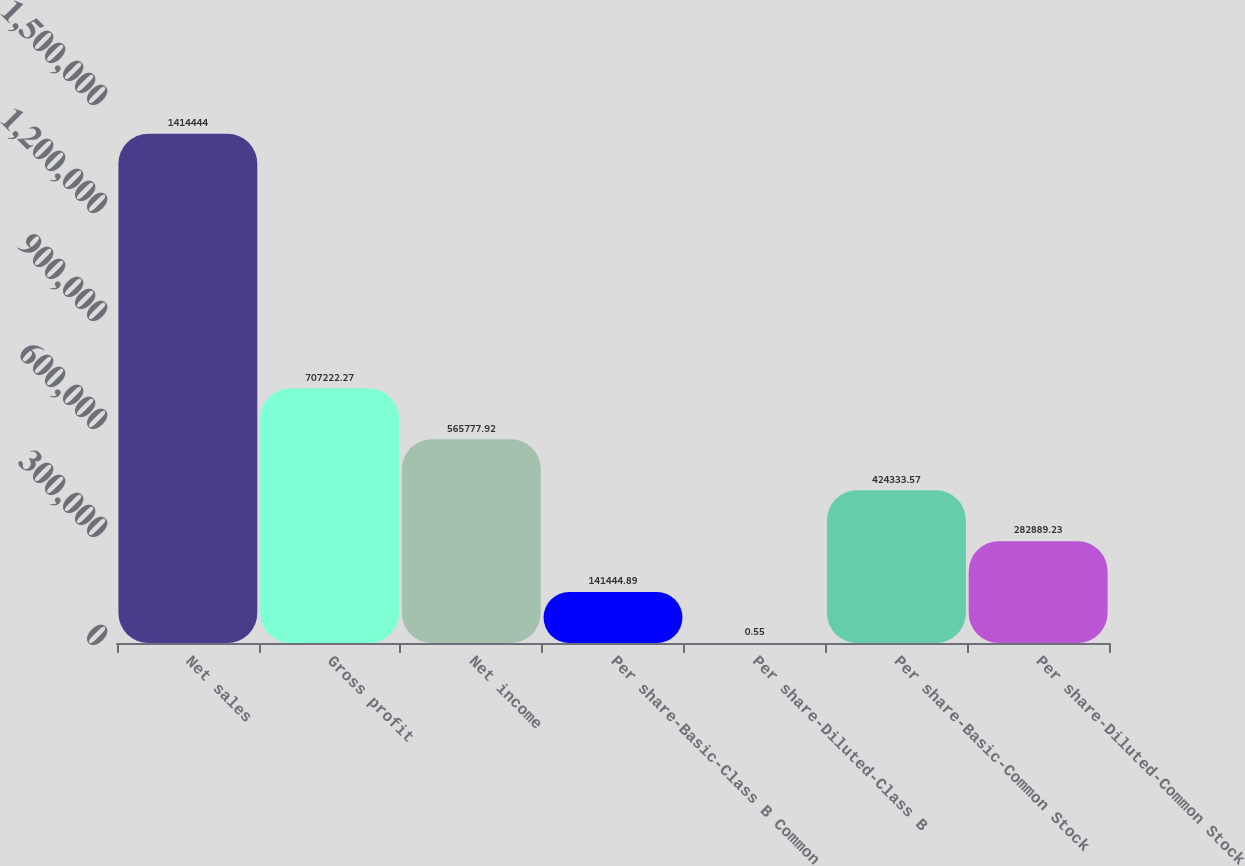<chart> <loc_0><loc_0><loc_500><loc_500><bar_chart><fcel>Net sales<fcel>Gross profit<fcel>Net income<fcel>Per share-Basic-Class B Common<fcel>Per share-Diluted-Class B<fcel>Per share-Basic-Common Stock<fcel>Per share-Diluted-Common Stock<nl><fcel>1.41444e+06<fcel>707222<fcel>565778<fcel>141445<fcel>0.55<fcel>424334<fcel>282889<nl></chart> 